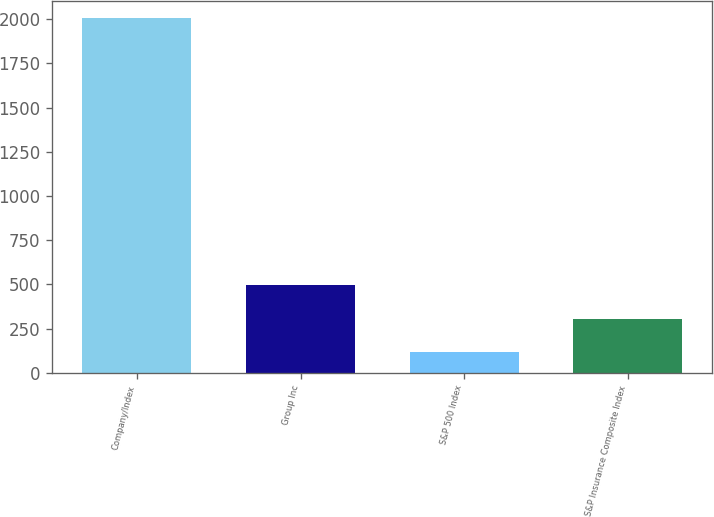<chart> <loc_0><loc_0><loc_500><loc_500><bar_chart><fcel>Company/Index<fcel>Group Inc<fcel>S&P 500 Index<fcel>S&P Insurance Composite Index<nl><fcel>2005<fcel>494.07<fcel>116.33<fcel>305.2<nl></chart> 